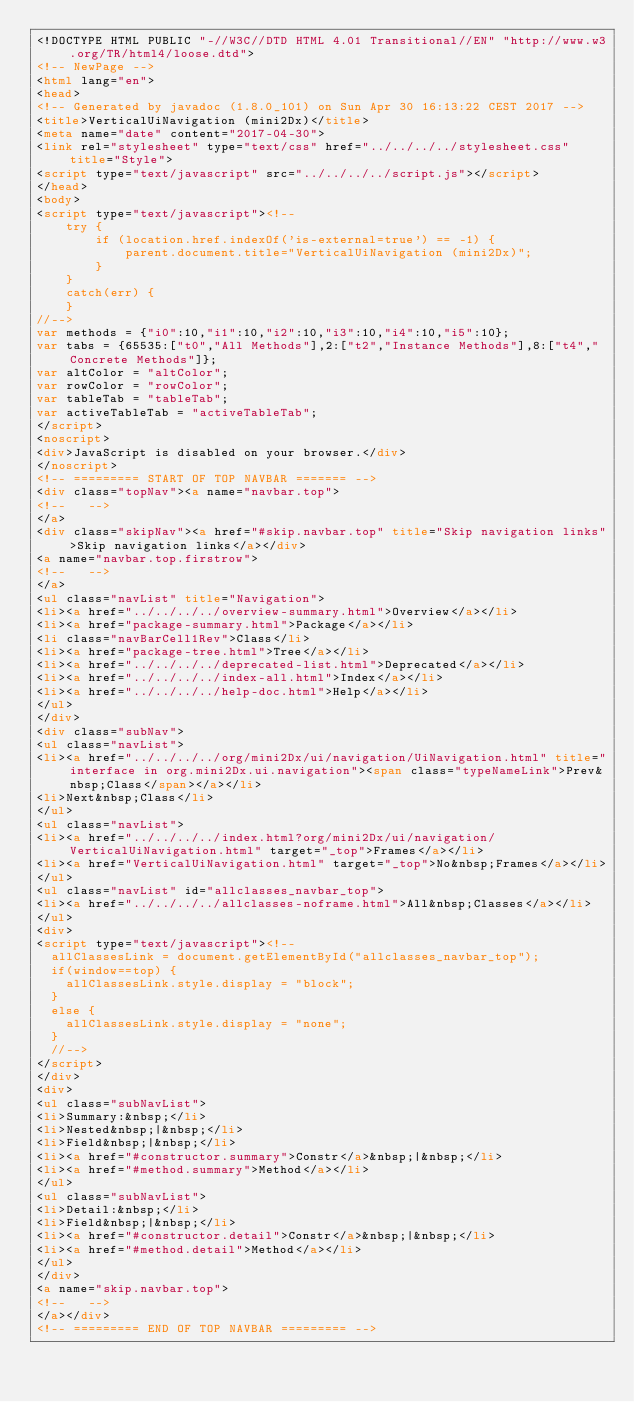Convert code to text. <code><loc_0><loc_0><loc_500><loc_500><_HTML_><!DOCTYPE HTML PUBLIC "-//W3C//DTD HTML 4.01 Transitional//EN" "http://www.w3.org/TR/html4/loose.dtd">
<!-- NewPage -->
<html lang="en">
<head>
<!-- Generated by javadoc (1.8.0_101) on Sun Apr 30 16:13:22 CEST 2017 -->
<title>VerticalUiNavigation (mini2Dx)</title>
<meta name="date" content="2017-04-30">
<link rel="stylesheet" type="text/css" href="../../../../stylesheet.css" title="Style">
<script type="text/javascript" src="../../../../script.js"></script>
</head>
<body>
<script type="text/javascript"><!--
    try {
        if (location.href.indexOf('is-external=true') == -1) {
            parent.document.title="VerticalUiNavigation (mini2Dx)";
        }
    }
    catch(err) {
    }
//-->
var methods = {"i0":10,"i1":10,"i2":10,"i3":10,"i4":10,"i5":10};
var tabs = {65535:["t0","All Methods"],2:["t2","Instance Methods"],8:["t4","Concrete Methods"]};
var altColor = "altColor";
var rowColor = "rowColor";
var tableTab = "tableTab";
var activeTableTab = "activeTableTab";
</script>
<noscript>
<div>JavaScript is disabled on your browser.</div>
</noscript>
<!-- ========= START OF TOP NAVBAR ======= -->
<div class="topNav"><a name="navbar.top">
<!--   -->
</a>
<div class="skipNav"><a href="#skip.navbar.top" title="Skip navigation links">Skip navigation links</a></div>
<a name="navbar.top.firstrow">
<!--   -->
</a>
<ul class="navList" title="Navigation">
<li><a href="../../../../overview-summary.html">Overview</a></li>
<li><a href="package-summary.html">Package</a></li>
<li class="navBarCell1Rev">Class</li>
<li><a href="package-tree.html">Tree</a></li>
<li><a href="../../../../deprecated-list.html">Deprecated</a></li>
<li><a href="../../../../index-all.html">Index</a></li>
<li><a href="../../../../help-doc.html">Help</a></li>
</ul>
</div>
<div class="subNav">
<ul class="navList">
<li><a href="../../../../org/mini2Dx/ui/navigation/UiNavigation.html" title="interface in org.mini2Dx.ui.navigation"><span class="typeNameLink">Prev&nbsp;Class</span></a></li>
<li>Next&nbsp;Class</li>
</ul>
<ul class="navList">
<li><a href="../../../../index.html?org/mini2Dx/ui/navigation/VerticalUiNavigation.html" target="_top">Frames</a></li>
<li><a href="VerticalUiNavigation.html" target="_top">No&nbsp;Frames</a></li>
</ul>
<ul class="navList" id="allclasses_navbar_top">
<li><a href="../../../../allclasses-noframe.html">All&nbsp;Classes</a></li>
</ul>
<div>
<script type="text/javascript"><!--
  allClassesLink = document.getElementById("allclasses_navbar_top");
  if(window==top) {
    allClassesLink.style.display = "block";
  }
  else {
    allClassesLink.style.display = "none";
  }
  //-->
</script>
</div>
<div>
<ul class="subNavList">
<li>Summary:&nbsp;</li>
<li>Nested&nbsp;|&nbsp;</li>
<li>Field&nbsp;|&nbsp;</li>
<li><a href="#constructor.summary">Constr</a>&nbsp;|&nbsp;</li>
<li><a href="#method.summary">Method</a></li>
</ul>
<ul class="subNavList">
<li>Detail:&nbsp;</li>
<li>Field&nbsp;|&nbsp;</li>
<li><a href="#constructor.detail">Constr</a>&nbsp;|&nbsp;</li>
<li><a href="#method.detail">Method</a></li>
</ul>
</div>
<a name="skip.navbar.top">
<!--   -->
</a></div>
<!-- ========= END OF TOP NAVBAR ========= --></code> 